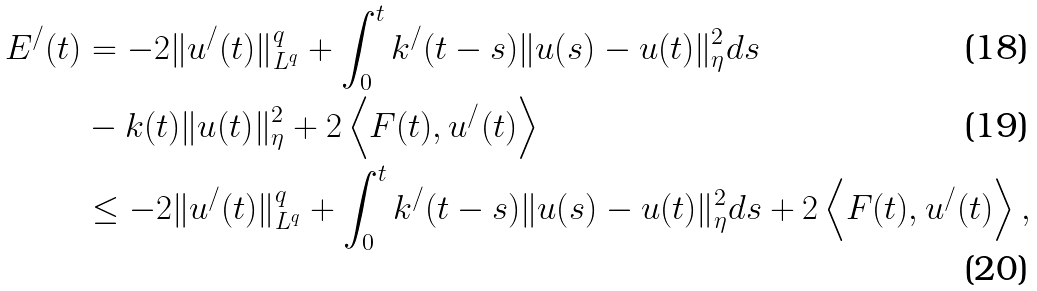<formula> <loc_0><loc_0><loc_500><loc_500>E ^ { / } ( t ) & = - 2 \| u ^ { / } ( t ) \| _ { L ^ { q } } ^ { q } + \int _ { 0 } ^ { t } k ^ { / } ( t - s ) \| u ( s ) - u ( t ) \| _ { \eta } ^ { 2 } d s \\ & - k ( t ) \| u ( t ) \| _ { \eta } ^ { 2 } + 2 \left < F ( t ) , u ^ { / } ( t ) \right > \\ & \leq - 2 \| u ^ { / } ( t ) \| _ { L ^ { q } } ^ { q } + \int _ { 0 } ^ { t } k ^ { / } ( t - s ) \| u ( s ) - u ( t ) \| _ { \eta } ^ { 2 } d s + 2 \left < F ( t ) , u ^ { / } ( t ) \right > ,</formula> 